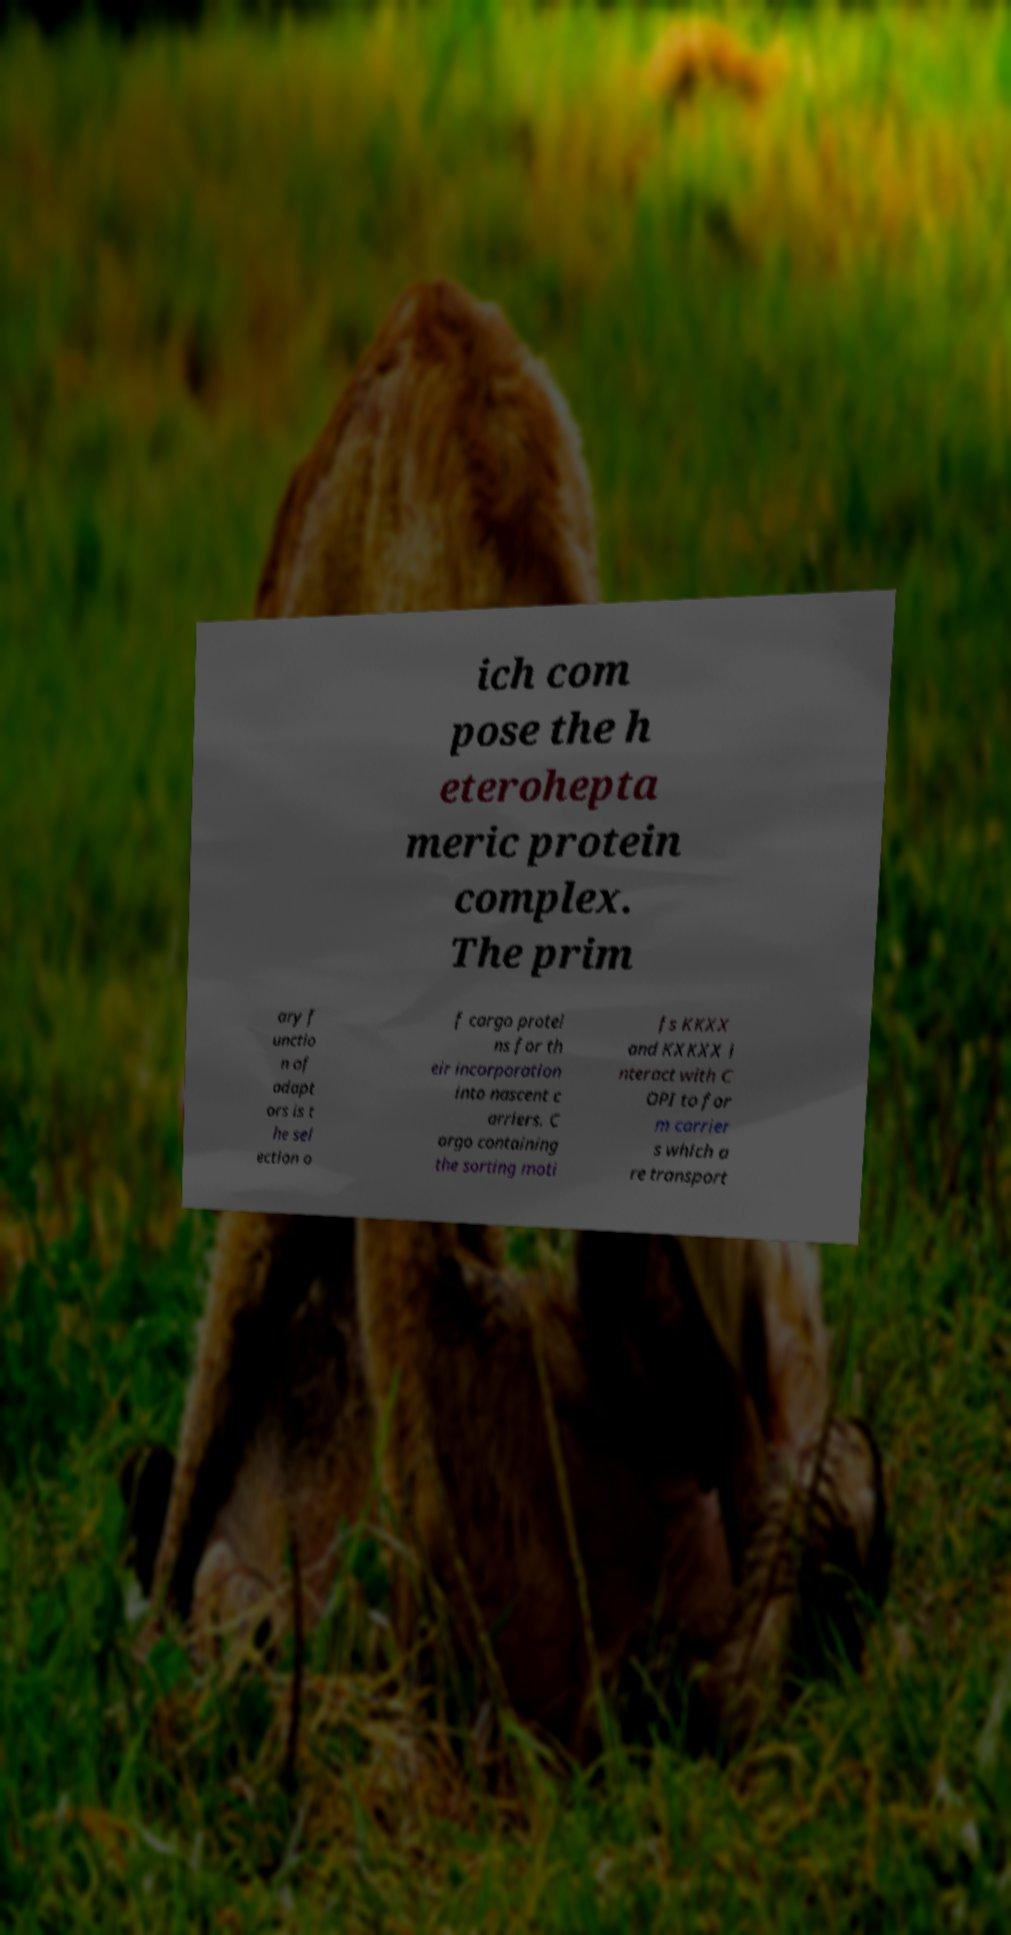Can you read and provide the text displayed in the image?This photo seems to have some interesting text. Can you extract and type it out for me? ich com pose the h eterohepta meric protein complex. The prim ary f unctio n of adapt ors is t he sel ection o f cargo protei ns for th eir incorporation into nascent c arriers. C argo containing the sorting moti fs KKXX and KXKXX i nteract with C OPI to for m carrier s which a re transport 